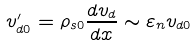Convert formula to latex. <formula><loc_0><loc_0><loc_500><loc_500>v _ { d 0 } ^ { \prime } = \rho _ { s 0 } \frac { d v _ { d } } { d x } \sim \varepsilon _ { n } v _ { d 0 }</formula> 